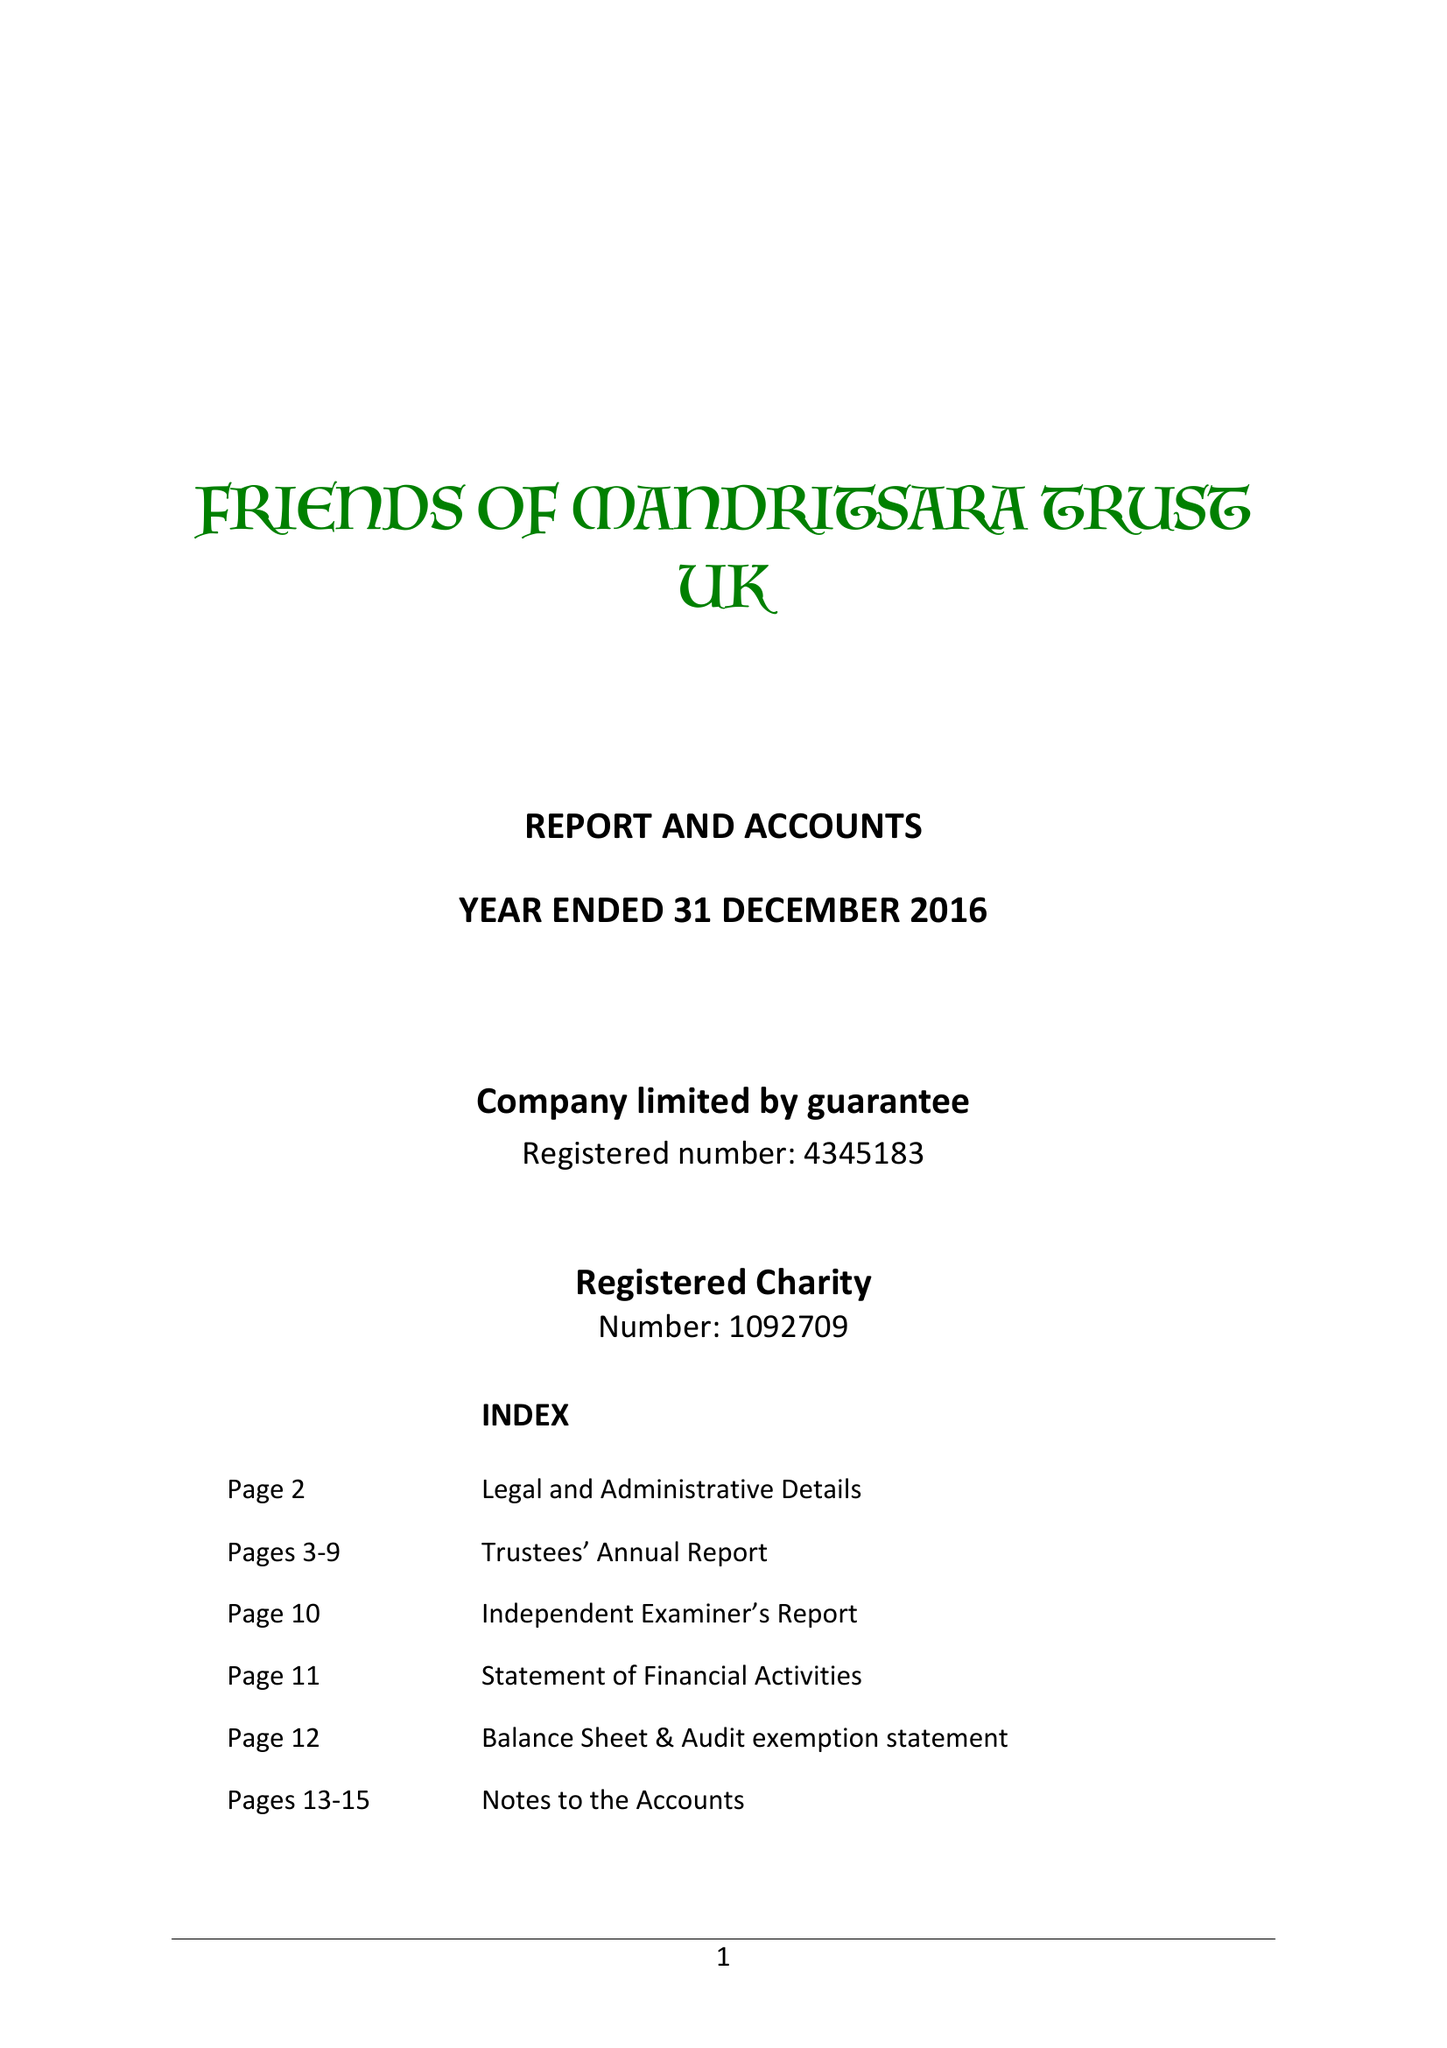What is the value for the address__postcode?
Answer the question using a single word or phrase. PE27 4SD 